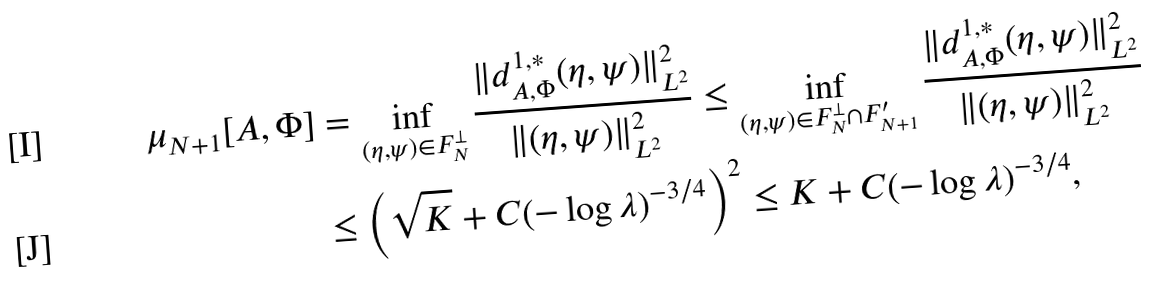<formula> <loc_0><loc_0><loc_500><loc_500>\mu _ { N + 1 } [ A , \Phi ] & = \inf _ { ( \eta , \psi ) \in F _ { N } ^ { \perp } } \frac { \| d _ { A , \Phi } ^ { 1 , * } ( \eta , \psi ) \| _ { L ^ { 2 } } ^ { 2 } } { \| ( \eta , \psi ) \| _ { L ^ { 2 } } ^ { 2 } } \leq \inf _ { ( \eta , \psi ) \in F _ { N } ^ { \perp } \cap F ^ { \prime } _ { N + 1 } } \frac { \| d _ { A , \Phi } ^ { 1 , * } ( \eta , \psi ) \| _ { L ^ { 2 } } ^ { 2 } } { \| ( \eta , \psi ) \| _ { L ^ { 2 } } ^ { 2 } } \\ & \leq \left ( \sqrt { K } + C ( - \log \lambda ) ^ { - 3 / 4 } \right ) ^ { 2 } \leq K + C ( - \log \lambda ) ^ { - 3 / 4 } ,</formula> 